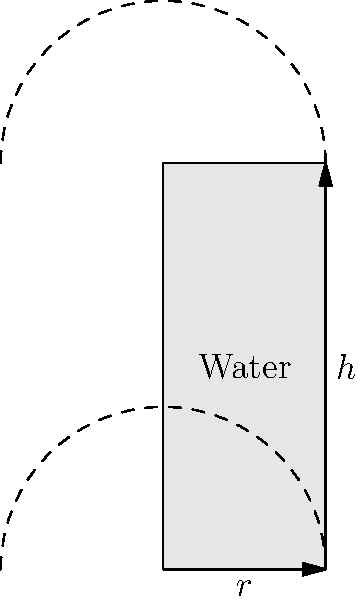A heritage building in Perth has been repurposed as a jazz club, and you've been asked to consult on the installation of a cylindrical water tank for the sprinkler system. The tank has a radius of 2 meters and a height of 5 meters. The water level in the tank is currently at 3 meters. What is the rate at which the volume of water in the tank is changing when the water level is rising at a rate of 0.1 meters per minute? Let's approach this step-by-step:

1) The volume of a cylinder is given by the formula:
   $$V = \pi r^2 h$$
   where $r$ is the radius and $h$ is the height of the water.

2) We need to find $\frac{dV}{dt}$ when $\frac{dh}{dt} = 0.1$ m/min.

3) Using the chain rule, we can write:
   $$\frac{dV}{dt} = \frac{dV}{dh} \cdot \frac{dh}{dt}$$

4) To find $\frac{dV}{dh}$, we differentiate the volume formula with respect to $h$:
   $$\frac{dV}{dh} = \pi r^2$$

5) We're given that $r = 2$ m, so:
   $$\frac{dV}{dh} = \pi (2)^2 = 4\pi \text{ m}^2$$

6) Now we can substitute this and the given $\frac{dh}{dt}$ into our equation:
   $$\frac{dV}{dt} = 4\pi \cdot 0.1 = 0.4\pi \text{ m}^3/\text{min}$$

7) To get a numerical value, we can calculate this:
   $$0.4\pi \approx 1.257 \text{ m}^3/\text{min}$$

Therefore, the volume is increasing at a rate of approximately 1.257 cubic meters per minute.
Answer: $1.257 \text{ m}^3/\text{min}$ 